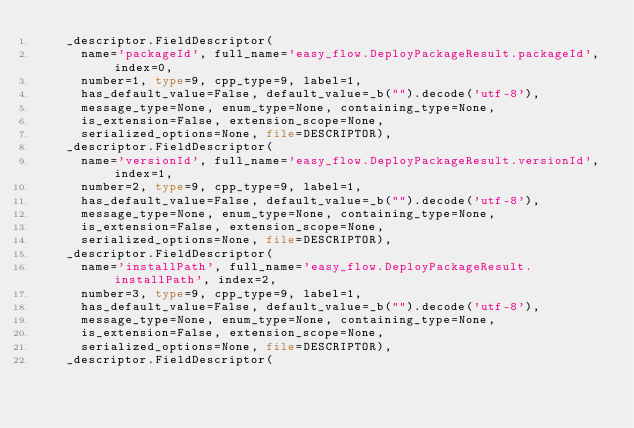Convert code to text. <code><loc_0><loc_0><loc_500><loc_500><_Python_>    _descriptor.FieldDescriptor(
      name='packageId', full_name='easy_flow.DeployPackageResult.packageId', index=0,
      number=1, type=9, cpp_type=9, label=1,
      has_default_value=False, default_value=_b("").decode('utf-8'),
      message_type=None, enum_type=None, containing_type=None,
      is_extension=False, extension_scope=None,
      serialized_options=None, file=DESCRIPTOR),
    _descriptor.FieldDescriptor(
      name='versionId', full_name='easy_flow.DeployPackageResult.versionId', index=1,
      number=2, type=9, cpp_type=9, label=1,
      has_default_value=False, default_value=_b("").decode('utf-8'),
      message_type=None, enum_type=None, containing_type=None,
      is_extension=False, extension_scope=None,
      serialized_options=None, file=DESCRIPTOR),
    _descriptor.FieldDescriptor(
      name='installPath', full_name='easy_flow.DeployPackageResult.installPath', index=2,
      number=3, type=9, cpp_type=9, label=1,
      has_default_value=False, default_value=_b("").decode('utf-8'),
      message_type=None, enum_type=None, containing_type=None,
      is_extension=False, extension_scope=None,
      serialized_options=None, file=DESCRIPTOR),
    _descriptor.FieldDescriptor(</code> 